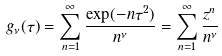<formula> <loc_0><loc_0><loc_500><loc_500>g _ { \nu } ( \tau ) = \sum _ { n = 1 } ^ { \infty } \frac { \exp ( - n \tau ^ { 2 } ) } { n ^ { \nu } } = \sum _ { n = 1 } ^ { \infty } \frac { z ^ { n } } { n ^ { \nu } }</formula> 